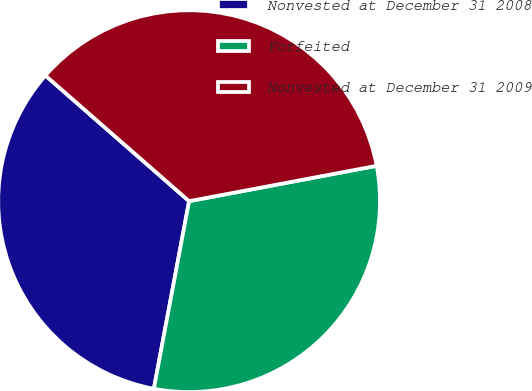<chart> <loc_0><loc_0><loc_500><loc_500><pie_chart><fcel>Nonvested at December 31 2008<fcel>Forfeited<fcel>Nonvested at December 31 2009<nl><fcel>33.48%<fcel>30.92%<fcel>35.6%<nl></chart> 